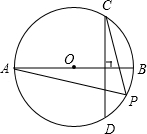Can you explain why angle CPA is half of the measure of arc BCD in the given image? In a circle, the measure of an inscribed angle is always half the measure of the arc it subtends. Since angle CPA is an inscribed angle subtending arc BCD, its measure is half of arc BCD. This principle follows from the properties of circles where the angle formed inside the circle by chords is always half the arc covered by these chords opposite the angle. 